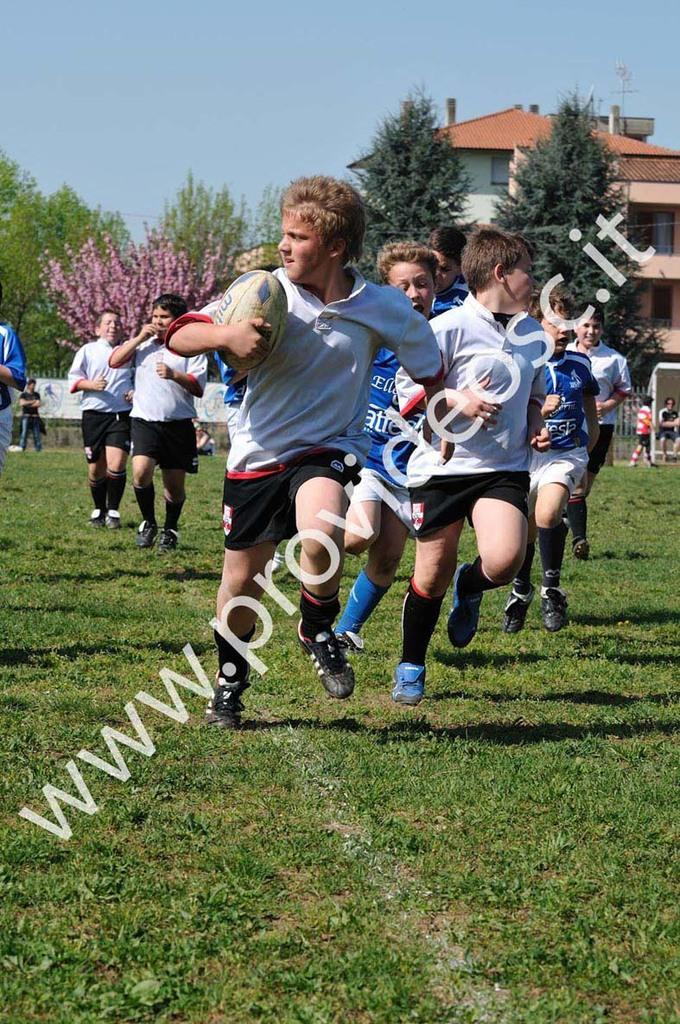What sport are the people playing in the image? The people are playing rugby in the image. What type of surface are they playing on? There is grass at the bottom of the image. What can be seen in the background of the image? There are trees and buildings in the background of the image. What is visible at the top of the image? The sky is visible at the top of the image. Is there any text present in the image? Yes, there is text on the picture. How many people are wearing a badge in the image? There is no mention of badges in the image, so it is impossible to determine how many people might be wearing one. What type of crowd can be seen in the image? There is no crowd present in the image; it features a rugby game with a limited number of players. 